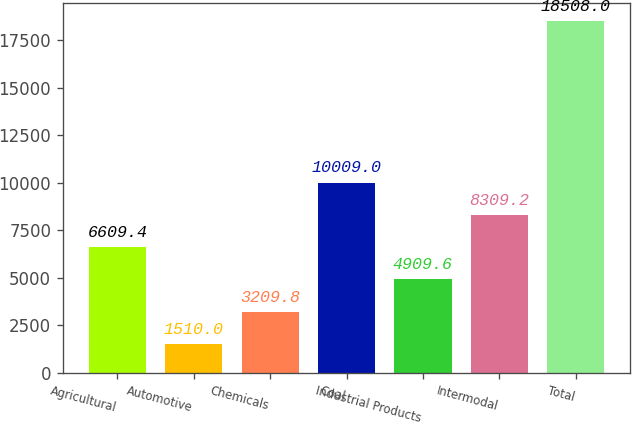Convert chart. <chart><loc_0><loc_0><loc_500><loc_500><bar_chart><fcel>Agricultural<fcel>Automotive<fcel>Chemicals<fcel>Coal<fcel>Industrial Products<fcel>Intermodal<fcel>Total<nl><fcel>6609.4<fcel>1510<fcel>3209.8<fcel>10009<fcel>4909.6<fcel>8309.2<fcel>18508<nl></chart> 